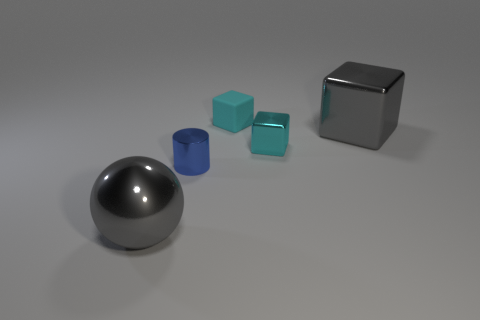Is the number of big yellow objects less than the number of small cyan metal objects?
Your answer should be compact. Yes. There is a metal thing that is both behind the tiny cylinder and left of the gray metallic cube; how big is it?
Make the answer very short. Small. Do the cylinder and the rubber thing have the same size?
Ensure brevity in your answer.  Yes. There is a metal cylinder that is in front of the tiny cyan matte object; does it have the same color as the matte thing?
Provide a short and direct response. No. There is a small metallic cylinder; how many blue metal things are to the right of it?
Offer a very short reply. 0. Is the number of blue metal cylinders greater than the number of large gray metallic things?
Your answer should be very brief. No. There is a thing that is to the left of the cyan metallic object and behind the small blue cylinder; what shape is it?
Your response must be concise. Cube. Are there any big shiny objects?
Offer a terse response. Yes. There is a gray object that is the same shape as the cyan rubber object; what material is it?
Give a very brief answer. Metal. What shape is the gray metal thing that is to the right of the large metallic thing that is left of the big object that is behind the blue shiny cylinder?
Offer a very short reply. Cube. 